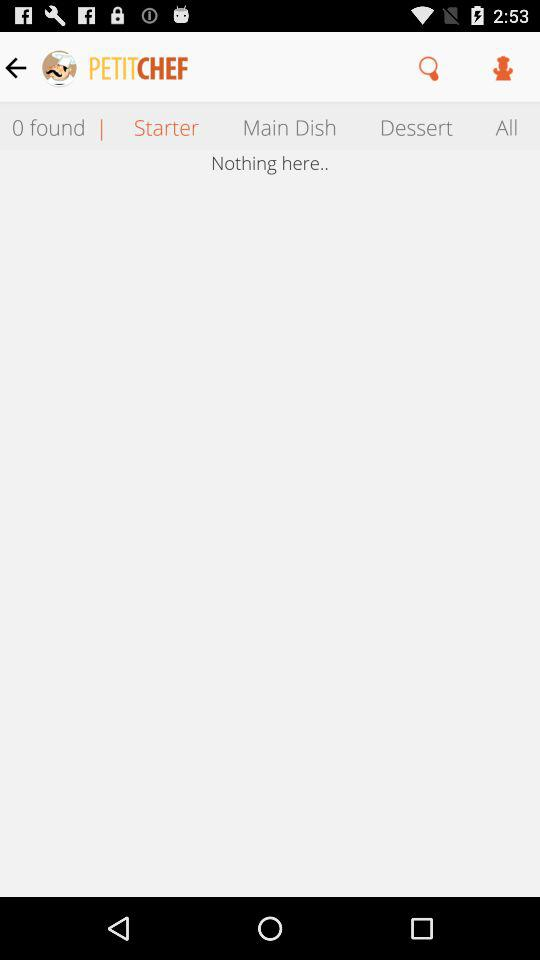What is the name of the application? The name of the application is "PETITCHEF". 